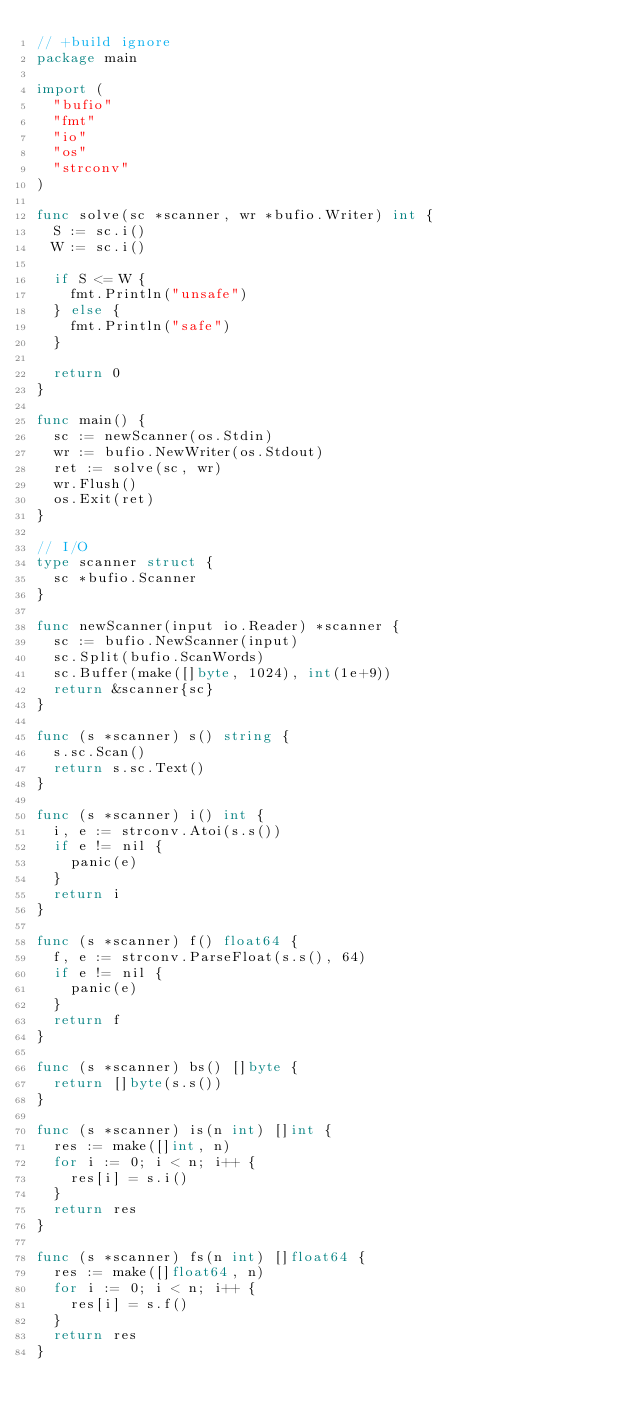<code> <loc_0><loc_0><loc_500><loc_500><_Go_>// +build ignore
package main

import (
	"bufio"
	"fmt"
	"io"
	"os"
	"strconv"
)

func solve(sc *scanner, wr *bufio.Writer) int {
	S := sc.i()
	W := sc.i()

	if S <= W {
		fmt.Println("unsafe")
	} else {
		fmt.Println("safe")
	}

	return 0
}

func main() {
	sc := newScanner(os.Stdin)
	wr := bufio.NewWriter(os.Stdout)
	ret := solve(sc, wr)
	wr.Flush()
	os.Exit(ret)
}

// I/O
type scanner struct {
	sc *bufio.Scanner
}

func newScanner(input io.Reader) *scanner {
	sc := bufio.NewScanner(input)
	sc.Split(bufio.ScanWords)
	sc.Buffer(make([]byte, 1024), int(1e+9))
	return &scanner{sc}
}

func (s *scanner) s() string {
	s.sc.Scan()
	return s.sc.Text()
}

func (s *scanner) i() int {
	i, e := strconv.Atoi(s.s())
	if e != nil {
		panic(e)
	}
	return i
}

func (s *scanner) f() float64 {
	f, e := strconv.ParseFloat(s.s(), 64)
	if e != nil {
		panic(e)
	}
	return f
}

func (s *scanner) bs() []byte {
	return []byte(s.s())
}

func (s *scanner) is(n int) []int {
	res := make([]int, n)
	for i := 0; i < n; i++ {
		res[i] = s.i()
	}
	return res
}

func (s *scanner) fs(n int) []float64 {
	res := make([]float64, n)
	for i := 0; i < n; i++ {
		res[i] = s.f()
	}
	return res
}
</code> 